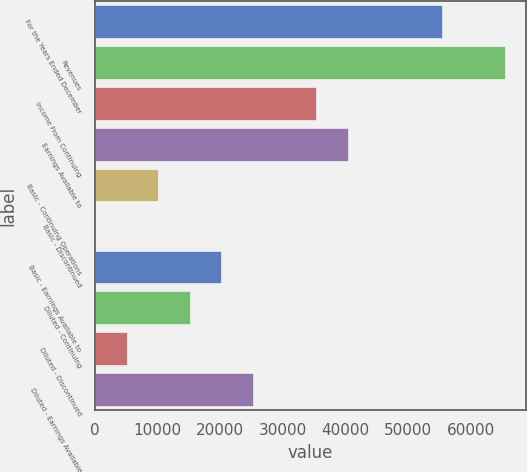Convert chart. <chart><loc_0><loc_0><loc_500><loc_500><bar_chart><fcel>For the Years Ended December<fcel>Revenues<fcel>Income From Continuing<fcel>Earnings Available to<fcel>Basic - Continuing Operations<fcel>Basic - Discontinued<fcel>Basic - Earnings Available to<fcel>Diluted - Continuing<fcel>Diluted - Discontinued<fcel>Diluted - Earnings Available<nl><fcel>55466.4<fcel>65551.2<fcel>35296.8<fcel>40339.2<fcel>10084.8<fcel>0.04<fcel>20169.6<fcel>15127.2<fcel>5042.44<fcel>25212<nl></chart> 